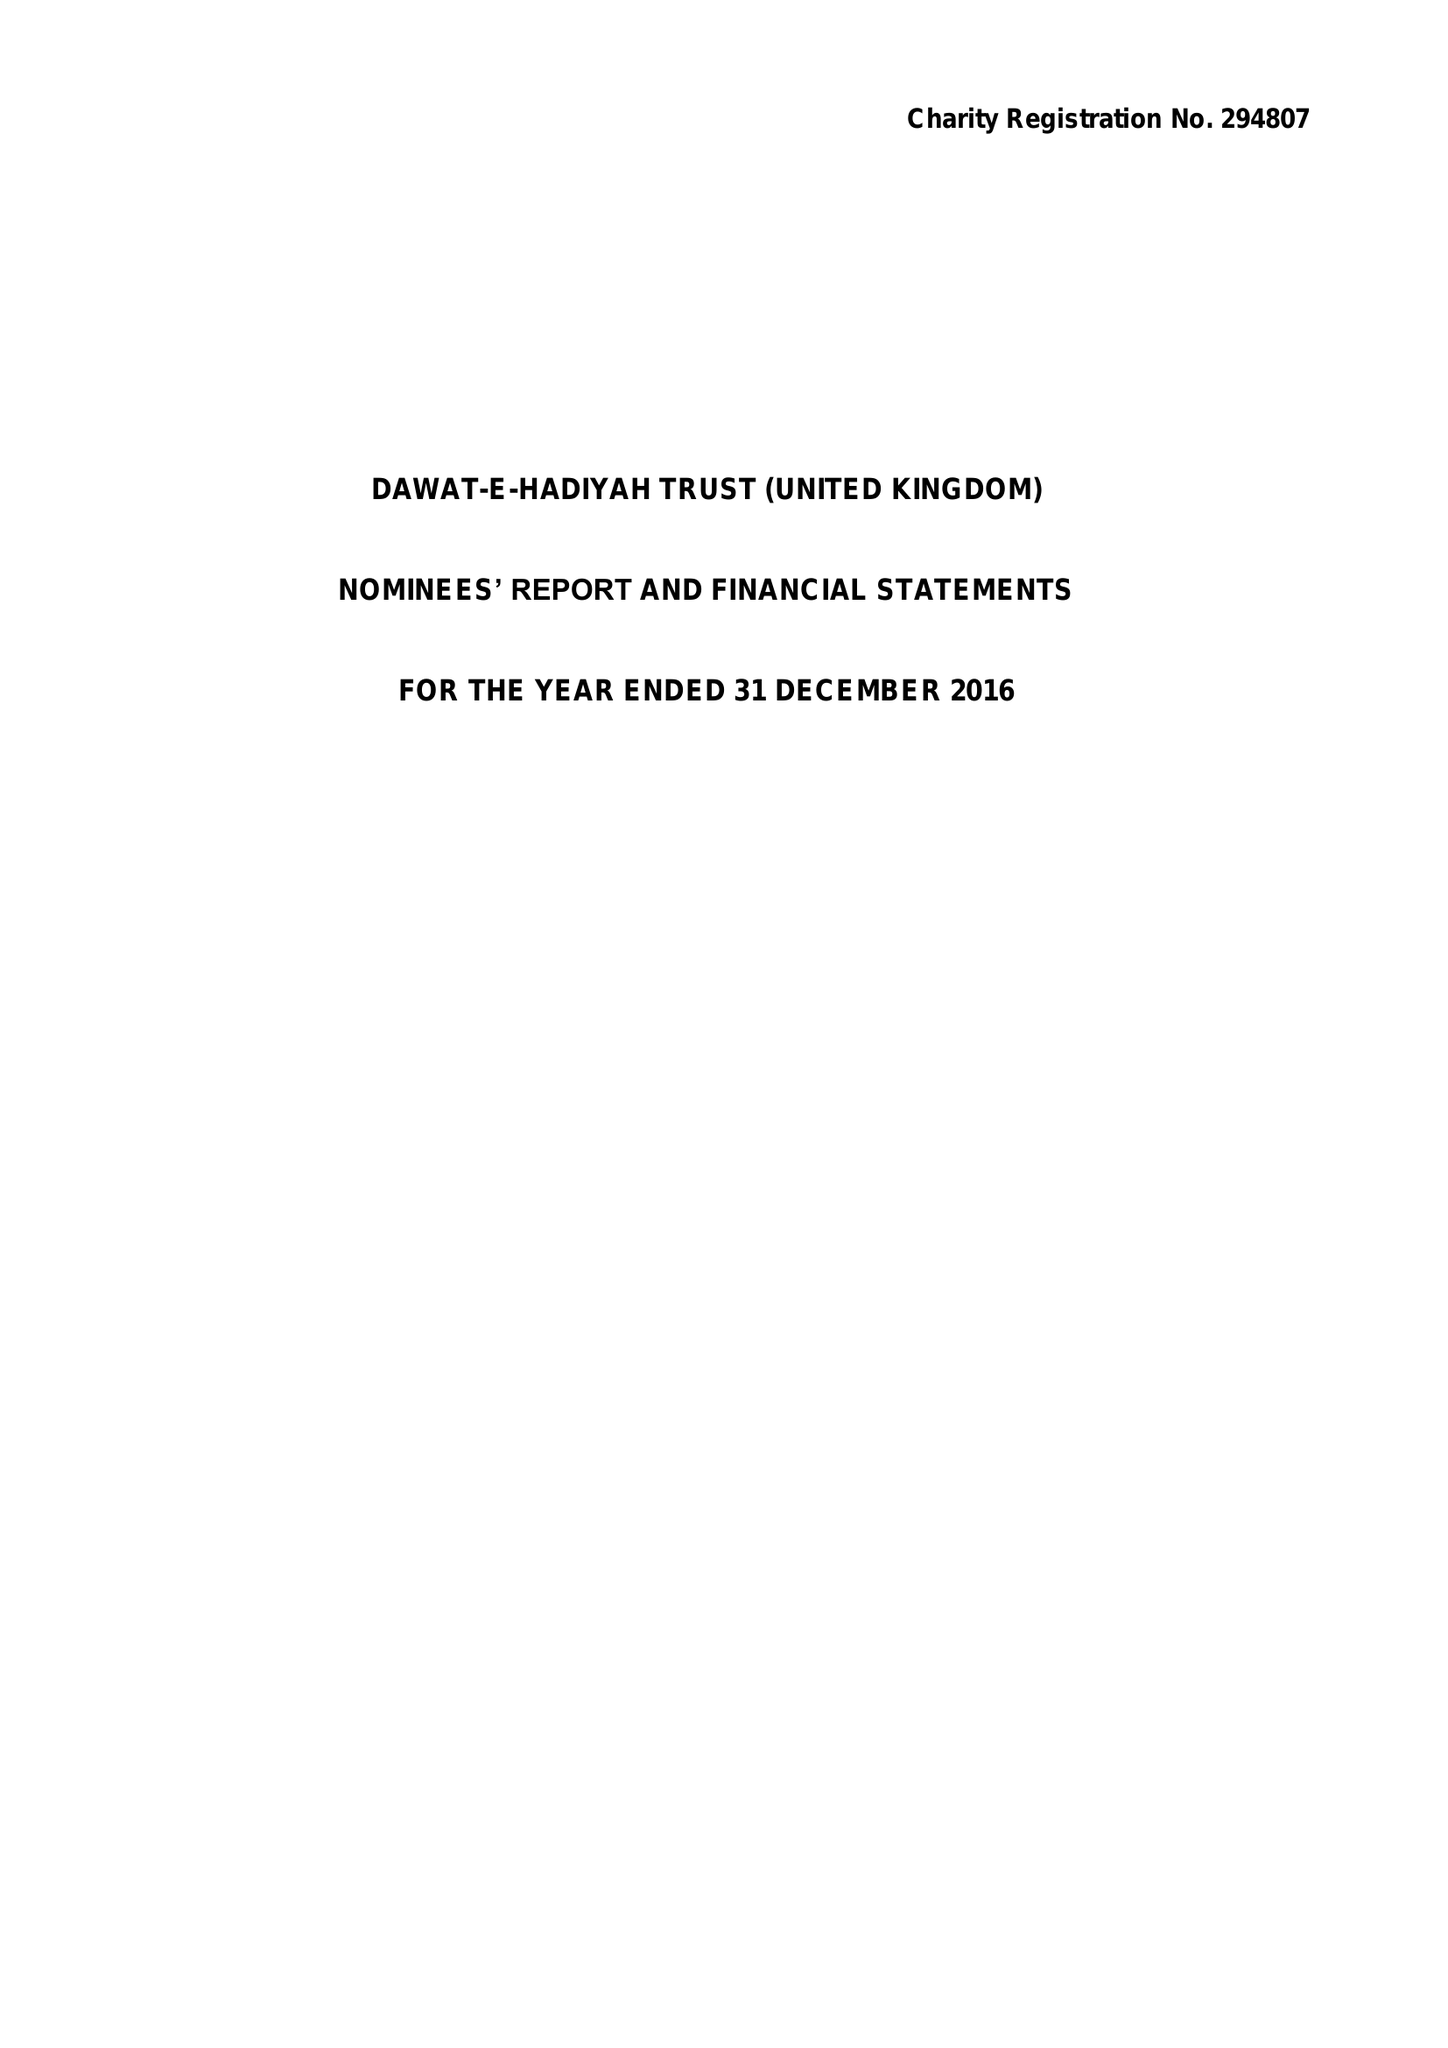What is the value for the address__street_line?
Answer the question using a single word or phrase. ROWDELL ROAD 